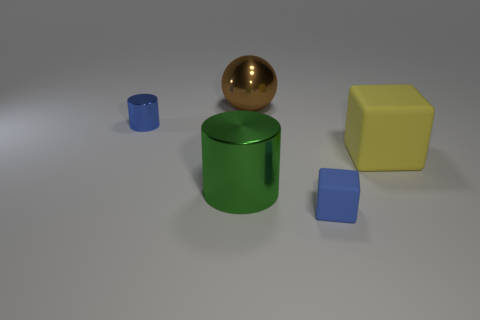There is a cylinder behind the shiny cylinder that is in front of the small object that is behind the big cube; what color is it?
Keep it short and to the point. Blue. What number of spheres are the same size as the blue matte object?
Provide a succinct answer. 0. What color is the tiny thing that is right of the metallic ball?
Your answer should be compact. Blue. How many other things are the same size as the green metallic object?
Provide a succinct answer. 2. There is a shiny object that is both right of the tiny cylinder and behind the yellow thing; how big is it?
Your answer should be compact. Large. Do the large cylinder and the tiny thing in front of the yellow rubber object have the same color?
Provide a short and direct response. No. Are there any other brown objects of the same shape as the tiny matte object?
Your answer should be compact. No. What number of things are either blue matte cubes or big shiny objects that are behind the big block?
Your response must be concise. 2. How many other objects are there of the same material as the big brown object?
Give a very brief answer. 2. What number of objects are cyan matte blocks or rubber things?
Offer a very short reply. 2. 